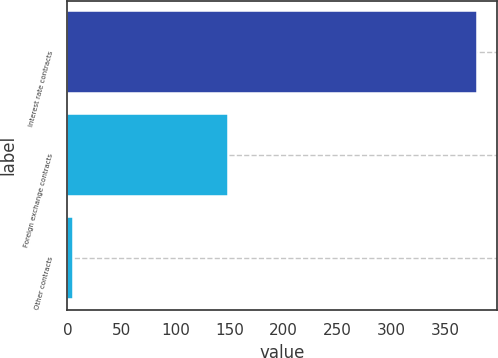Convert chart to OTSL. <chart><loc_0><loc_0><loc_500><loc_500><bar_chart><fcel>Interest rate contracts<fcel>Foreign exchange contracts<fcel>Other contracts<nl><fcel>379<fcel>149<fcel>5<nl></chart> 